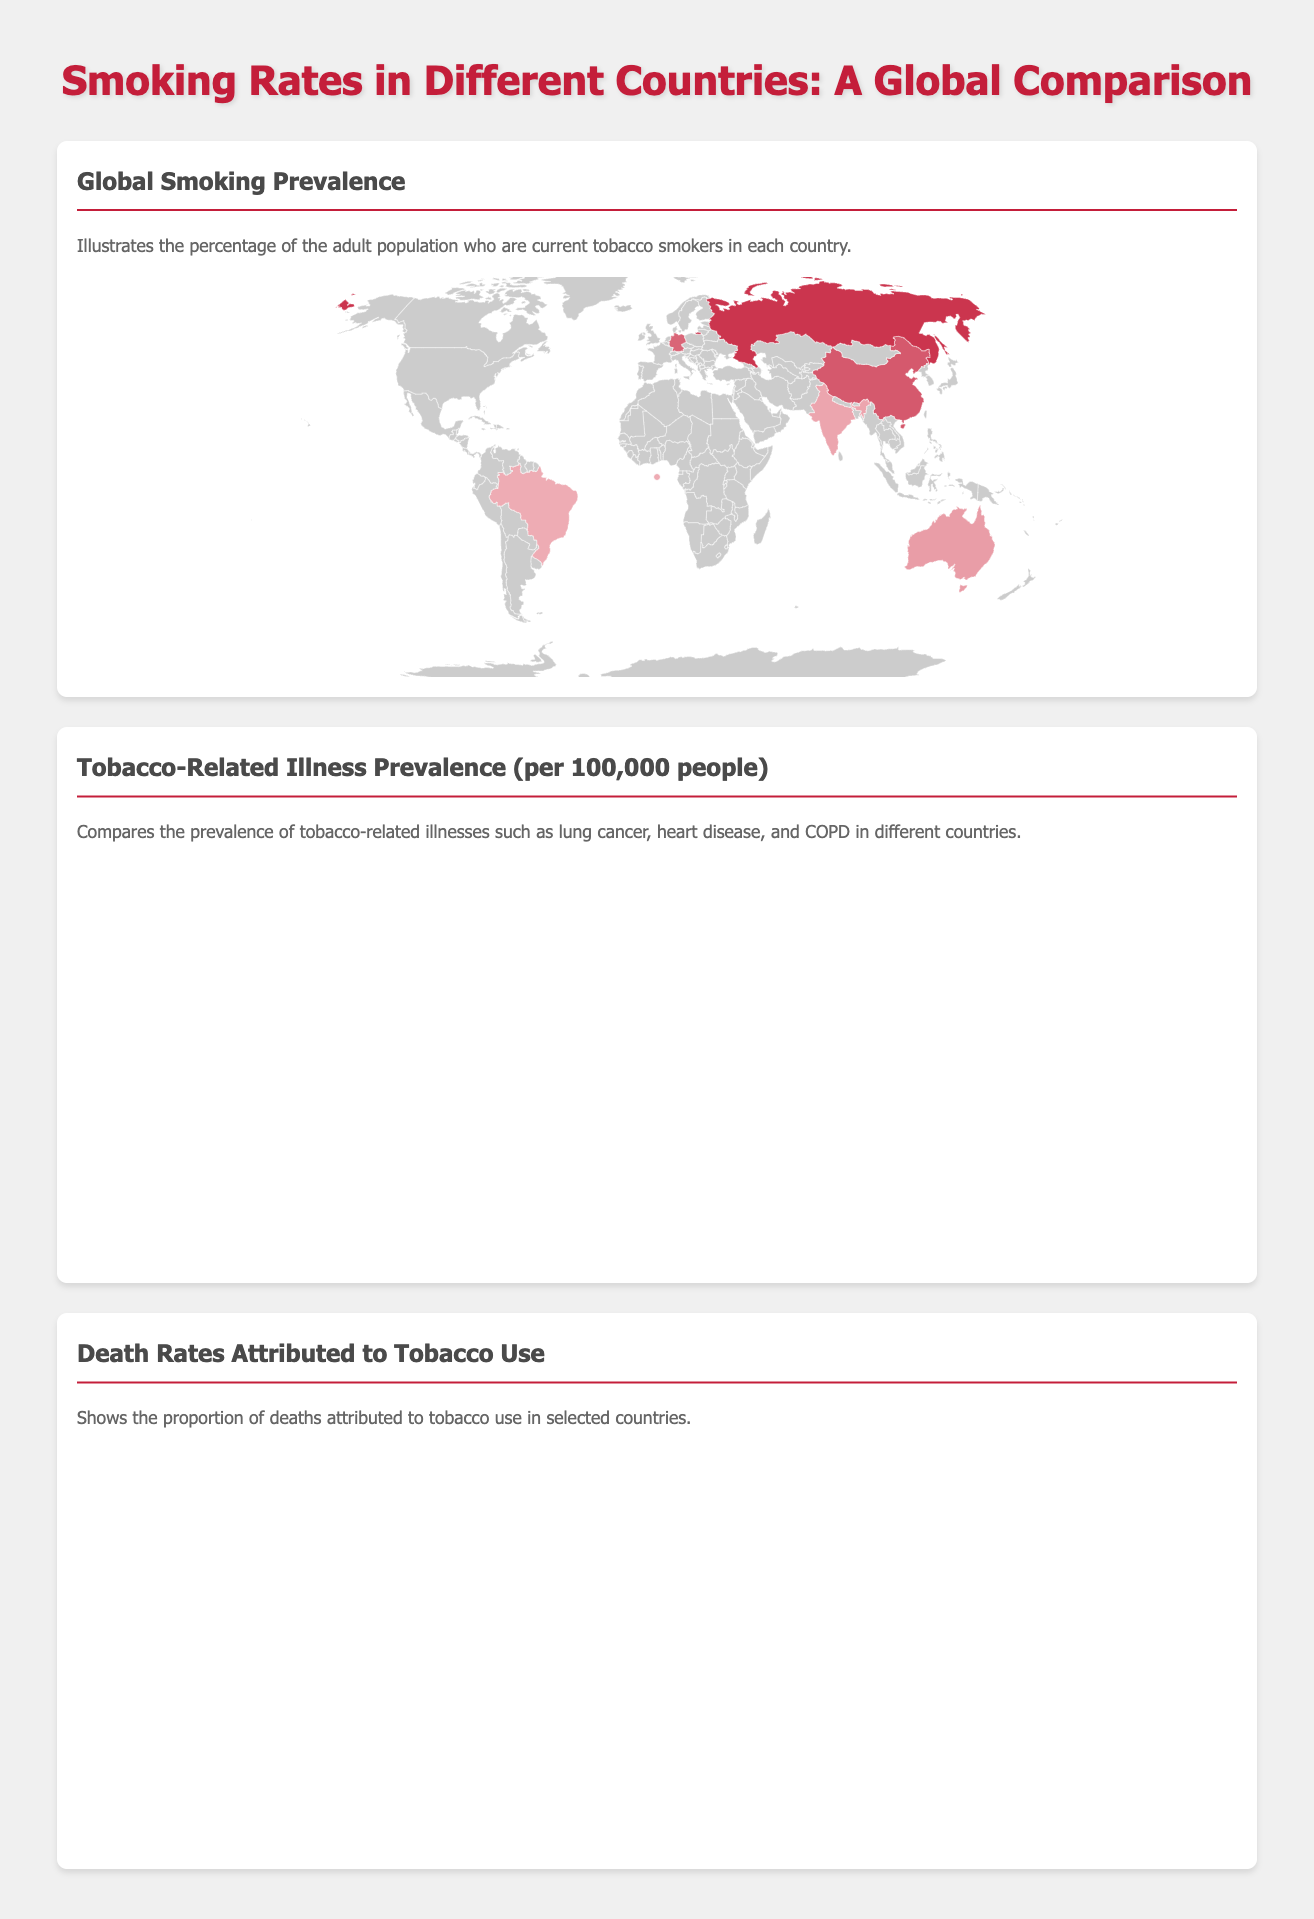What country has the highest smoking prevalence? The country with the highest smoking prevalence is indicated on the world map and in the data, which is Russia at 30.9%.
Answer: Russia How many countries are represented in the bar graph? The bar graph shows the prevalence of tobacco-related illnesses in eight different countries.
Answer: 8 What specific tobacco-related illness has the highest prevalence in the United States? The highest prevalence of tobacco-related illness in the United States according to the bar graph is heart disease at 115.0 per 100,000 people.
Answer: Heart Disease In which country does lung cancer have the highest prevalence? According to the bar graph data, Russia has the highest prevalence of lung cancer at 52.0 per 100,000 people.
Answer: Russia What is the death rate percentage attributed to tobacco use in Australia? The pie chart displays the proportion of deaths attributed to tobacco use, and Australia has a death rate percentage of 14.0%.
Answer: 14.0% Which country has the lowest death rate percentage from tobacco use? The pie chart data indicates that the lowest death rate percentage attributed to tobacco use is in Australia at 14.0%.
Answer: Australia What percentage of adults currently smoke in China? The smoking prevalence for adults in China is provided in the document, which is 24.7%.
Answer: 24.7% What type of comparison does the infographic primarily provide? The infographic primarily provides a comparison of smoking rates, tobacco-related illness prevalence, and death rates across different countries.
Answer: Comparison Which disease has the lowest reported prevalence per 100,000 in Germany? The bar graph lists the prevalence of tobacco-related illnesses in Germany, and COPD shows the lowest prevalence at 49.1 per 100,000 people.
Answer: COPD 